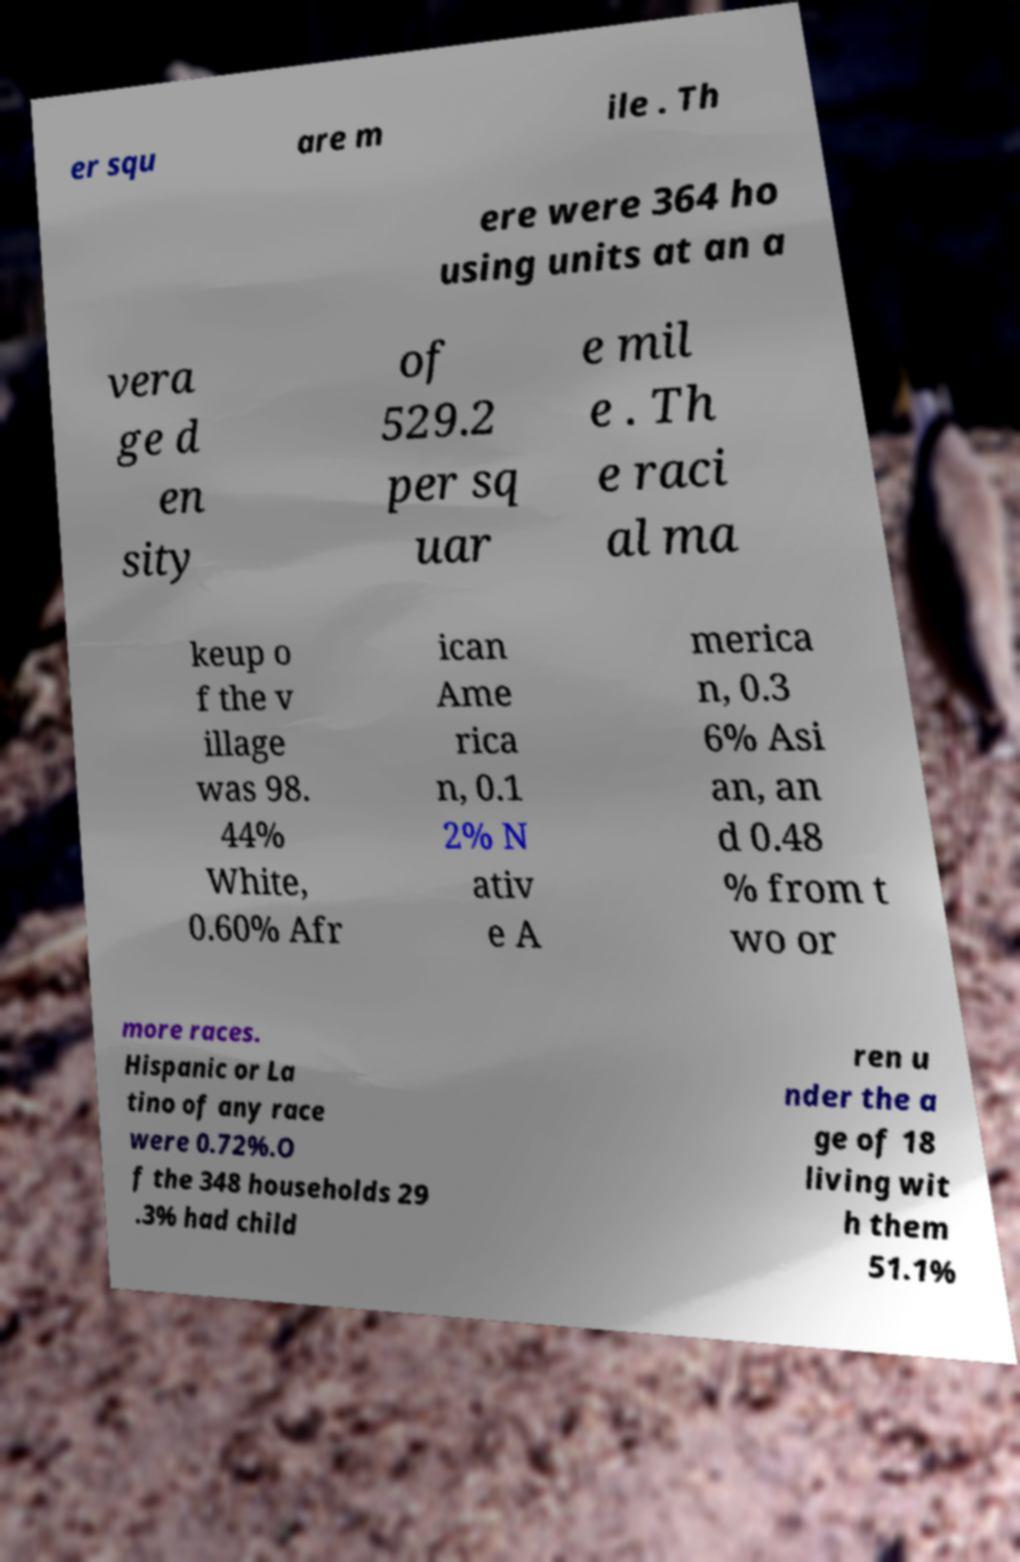Can you read and provide the text displayed in the image?This photo seems to have some interesting text. Can you extract and type it out for me? er squ are m ile . Th ere were 364 ho using units at an a vera ge d en sity of 529.2 per sq uar e mil e . Th e raci al ma keup o f the v illage was 98. 44% White, 0.60% Afr ican Ame rica n, 0.1 2% N ativ e A merica n, 0.3 6% Asi an, an d 0.48 % from t wo or more races. Hispanic or La tino of any race were 0.72%.O f the 348 households 29 .3% had child ren u nder the a ge of 18 living wit h them 51.1% 